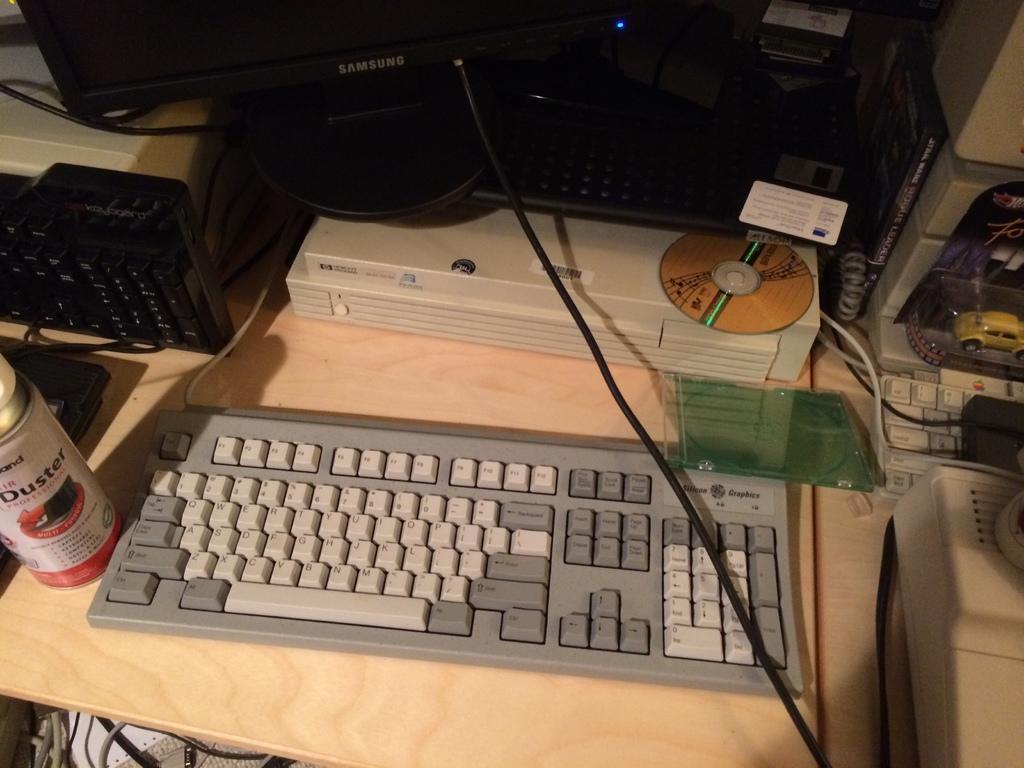Could you give a brief overview of what you see in this image? In the center of the image a table is there. On the table we can see a keyboard, LCD, screen, box, toy car, machine, a bottle and some objects are there. At the bottom left corner we can see some wires are there. 